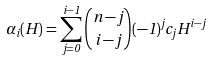Convert formula to latex. <formula><loc_0><loc_0><loc_500><loc_500>\alpha _ { i } ( H ) = \sum ^ { i - 1 } _ { j = 0 } \binom { n - j } { i - j } ( - 1 ) ^ { j } c _ { j } H ^ { i - j }</formula> 